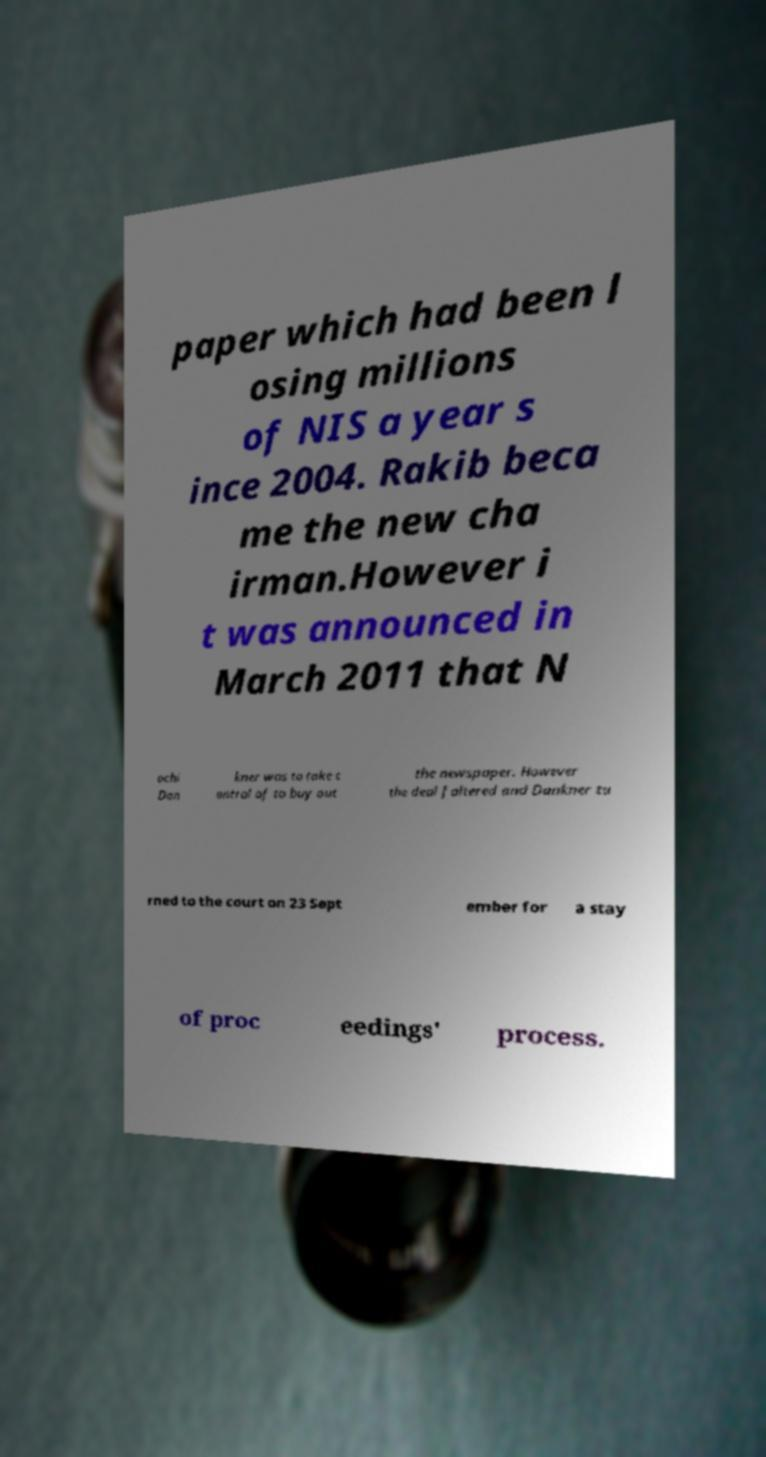What messages or text are displayed in this image? I need them in a readable, typed format. paper which had been l osing millions of NIS a year s ince 2004. Rakib beca me the new cha irman.However i t was announced in March 2011 that N ochi Dan kner was to take c ontrol of to buy out the newspaper. However the deal faltered and Dankner tu rned to the court on 23 Sept ember for a stay of proc eedings' process. 